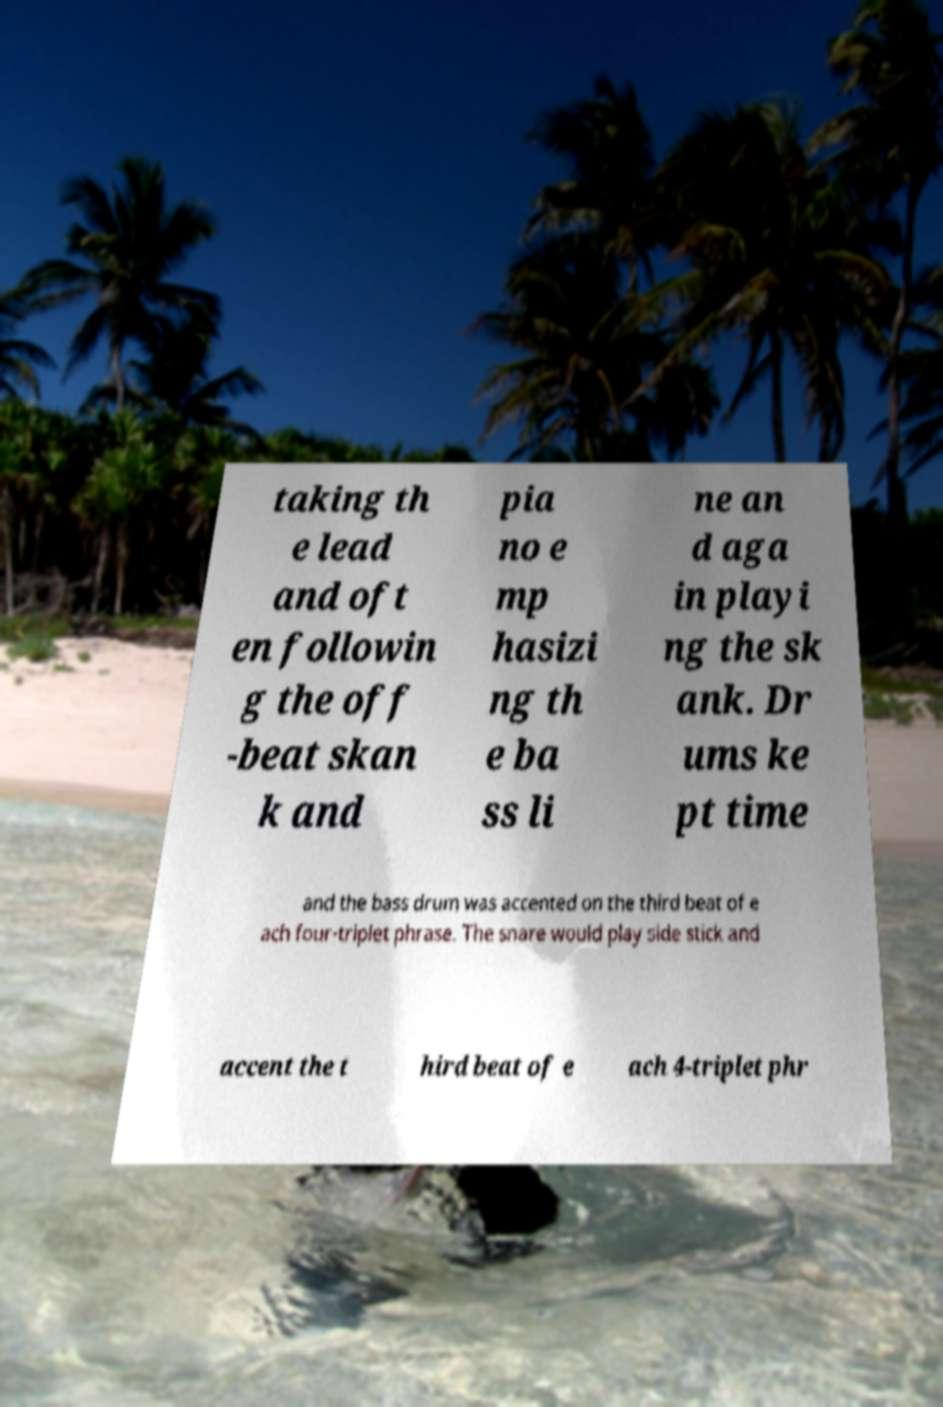Could you assist in decoding the text presented in this image and type it out clearly? taking th e lead and oft en followin g the off -beat skan k and pia no e mp hasizi ng th e ba ss li ne an d aga in playi ng the sk ank. Dr ums ke pt time and the bass drum was accented on the third beat of e ach four-triplet phrase. The snare would play side stick and accent the t hird beat of e ach 4-triplet phr 